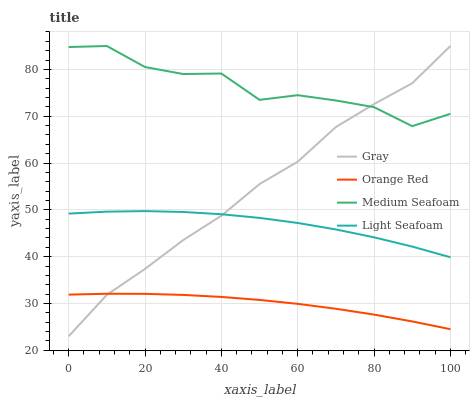Does Orange Red have the minimum area under the curve?
Answer yes or no. Yes. Does Medium Seafoam have the maximum area under the curve?
Answer yes or no. Yes. Does Light Seafoam have the minimum area under the curve?
Answer yes or no. No. Does Light Seafoam have the maximum area under the curve?
Answer yes or no. No. Is Orange Red the smoothest?
Answer yes or no. Yes. Is Medium Seafoam the roughest?
Answer yes or no. Yes. Is Light Seafoam the smoothest?
Answer yes or no. No. Is Light Seafoam the roughest?
Answer yes or no. No. Does Gray have the lowest value?
Answer yes or no. Yes. Does Light Seafoam have the lowest value?
Answer yes or no. No. Does Medium Seafoam have the highest value?
Answer yes or no. Yes. Does Light Seafoam have the highest value?
Answer yes or no. No. Is Orange Red less than Medium Seafoam?
Answer yes or no. Yes. Is Light Seafoam greater than Orange Red?
Answer yes or no. Yes. Does Gray intersect Orange Red?
Answer yes or no. Yes. Is Gray less than Orange Red?
Answer yes or no. No. Is Gray greater than Orange Red?
Answer yes or no. No. Does Orange Red intersect Medium Seafoam?
Answer yes or no. No. 